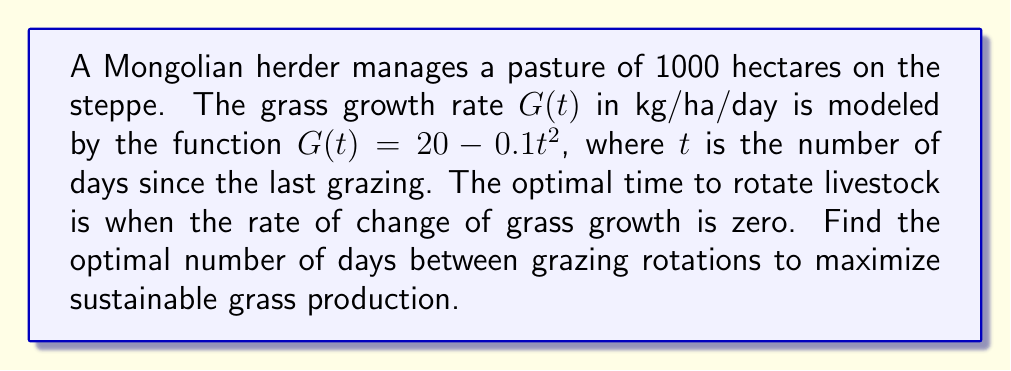Help me with this question. To find the optimal grazing rotation rate, we need to find when the rate of change of grass growth is zero. This involves taking the derivative of the grass growth function and setting it equal to zero.

1. The grass growth function is given by:
   $$G(t) = 20 - 0.1t^2$$

2. To find the rate of change, we take the derivative of $G(t)$ with respect to $t$:
   $$\frac{dG}{dt} = -0.2t$$

3. Set the derivative equal to zero to find the critical point:
   $$-0.2t = 0$$

4. Solve for $t$:
   $$t = 0$$

5. The second derivative is:
   $$\frac{d^2G}{dt^2} = -0.2$$

   Since this is negative, the critical point is a maximum.

6. However, $t = 0$ doesn't make sense in the context of grazing rotation. We need to find the maximum positive value of $t$ before the growth rate becomes negative.

7. Set $G(t) = 0$ and solve for $t$:
   $$20 - 0.1t^2 = 0$$
   $$0.1t^2 = 20$$
   $$t^2 = 200$$
   $$t = \sqrt{200} \approx 14.14$$

Therefore, the optimal grazing rotation is approximately 14 days, which allows for maximum sustainable grass production before the growth rate becomes negative.
Answer: 14 days 